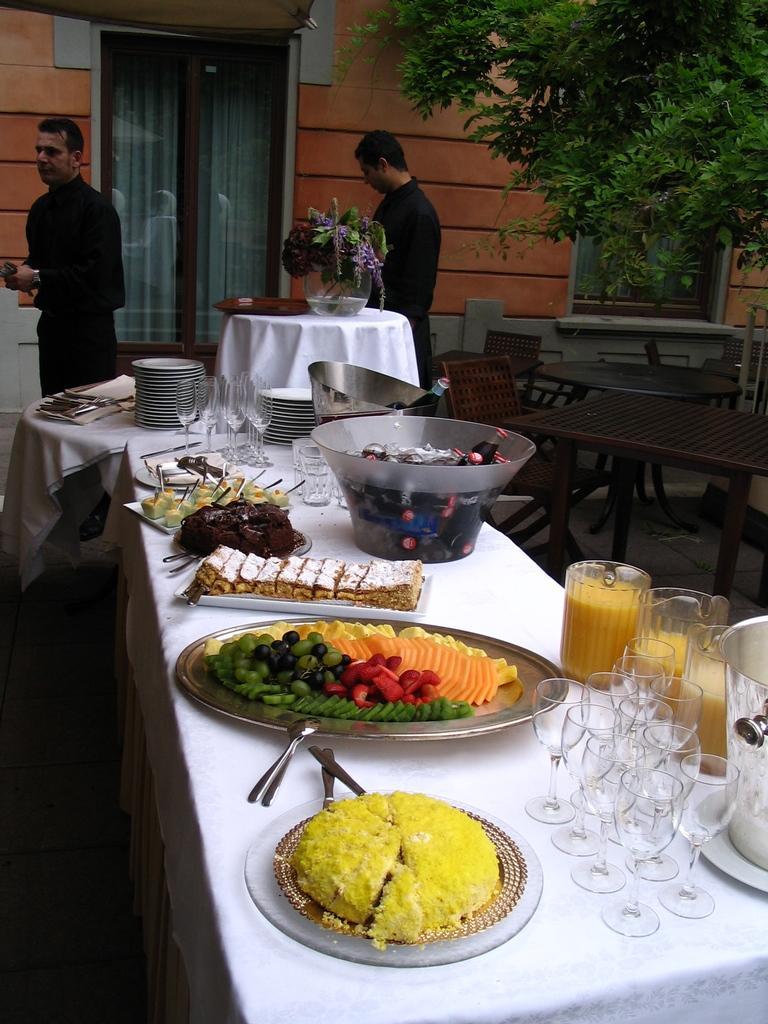In one or two sentences, can you explain what this image depicts? As we can see in the image there is a tree, building, door and two persons standing and in the front there is a table. On table there are plates, glasses and white color cloth. 